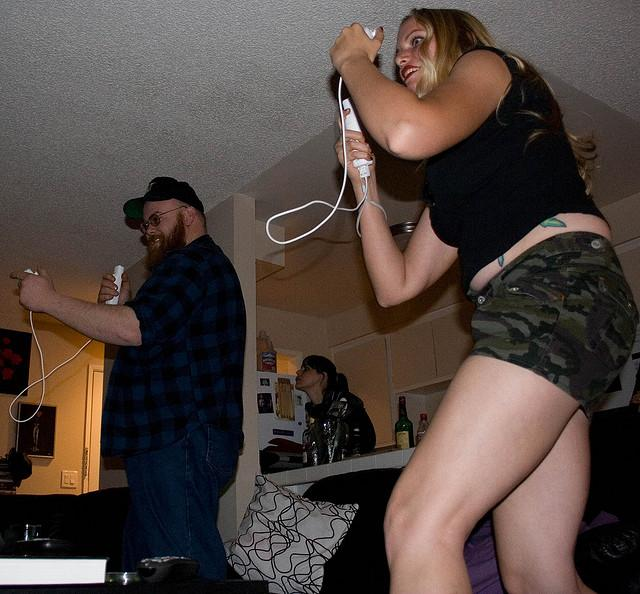What video game console is being played by the two people in front? wii 